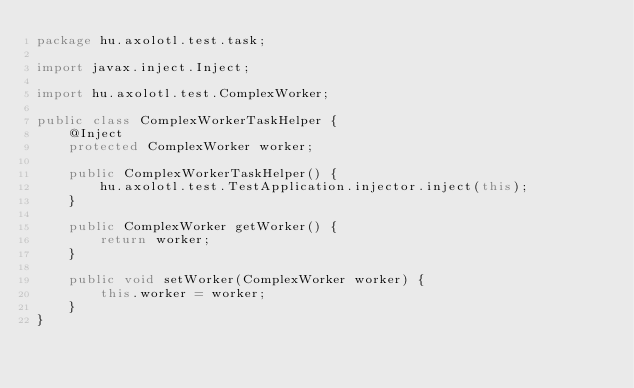Convert code to text. <code><loc_0><loc_0><loc_500><loc_500><_Java_>package hu.axolotl.test.task;

import javax.inject.Inject;

import hu.axolotl.test.ComplexWorker;

public class ComplexWorkerTaskHelper {
    @Inject
    protected ComplexWorker worker;

    public ComplexWorkerTaskHelper() {
        hu.axolotl.test.TestApplication.injector.inject(this);
    }

    public ComplexWorker getWorker() {
        return worker;
    }

    public void setWorker(ComplexWorker worker) {
        this.worker = worker;
    }
}</code> 